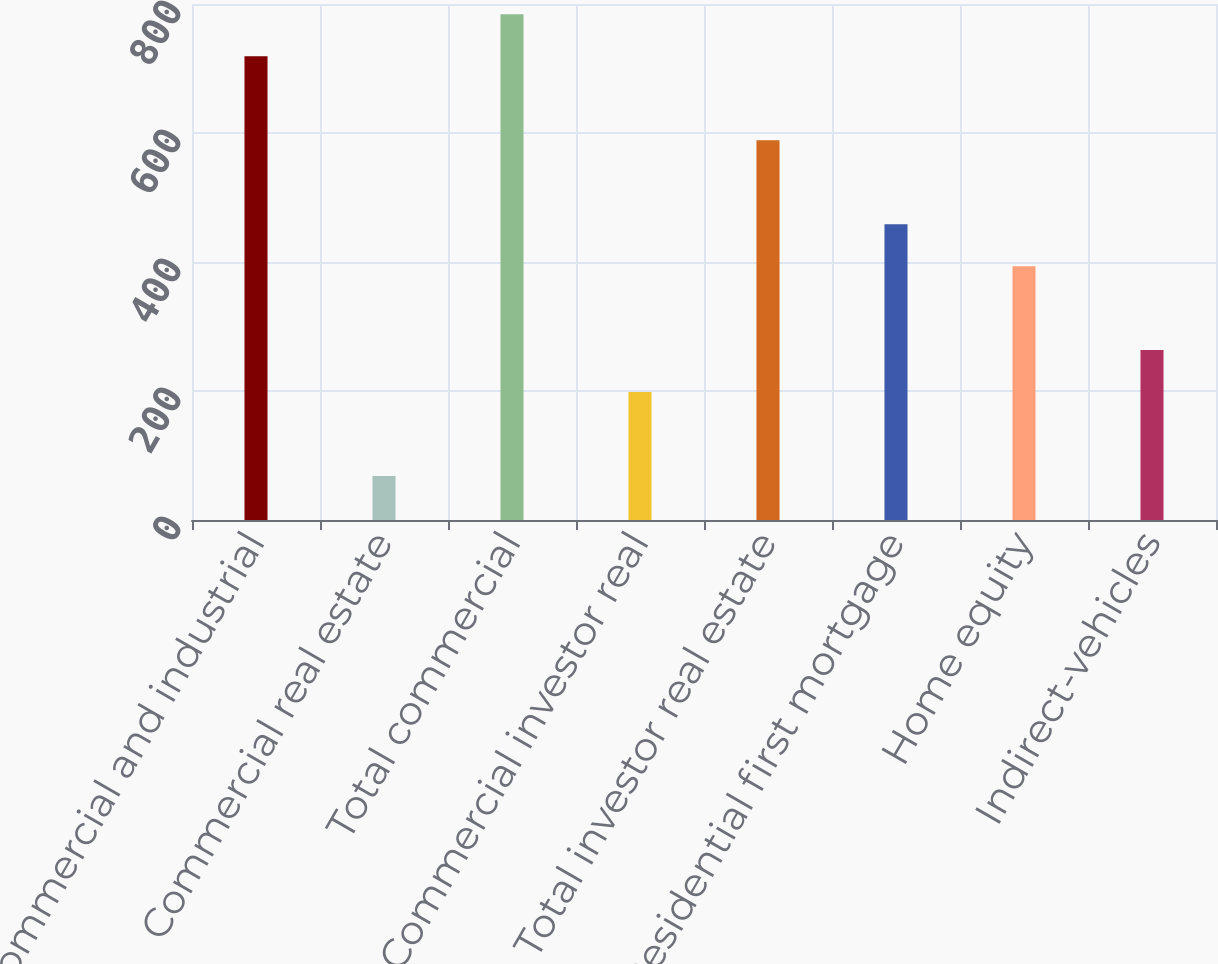<chart> <loc_0><loc_0><loc_500><loc_500><bar_chart><fcel>Commercial and industrial<fcel>Commercial real estate<fcel>Total commercial<fcel>Commercial investor real<fcel>Total investor real estate<fcel>Residential first mortgage<fcel>Home equity<fcel>Indirect-vehicles<nl><fcel>719.1<fcel>68.1<fcel>784.2<fcel>198.3<fcel>588.9<fcel>458.7<fcel>393.6<fcel>263.4<nl></chart> 